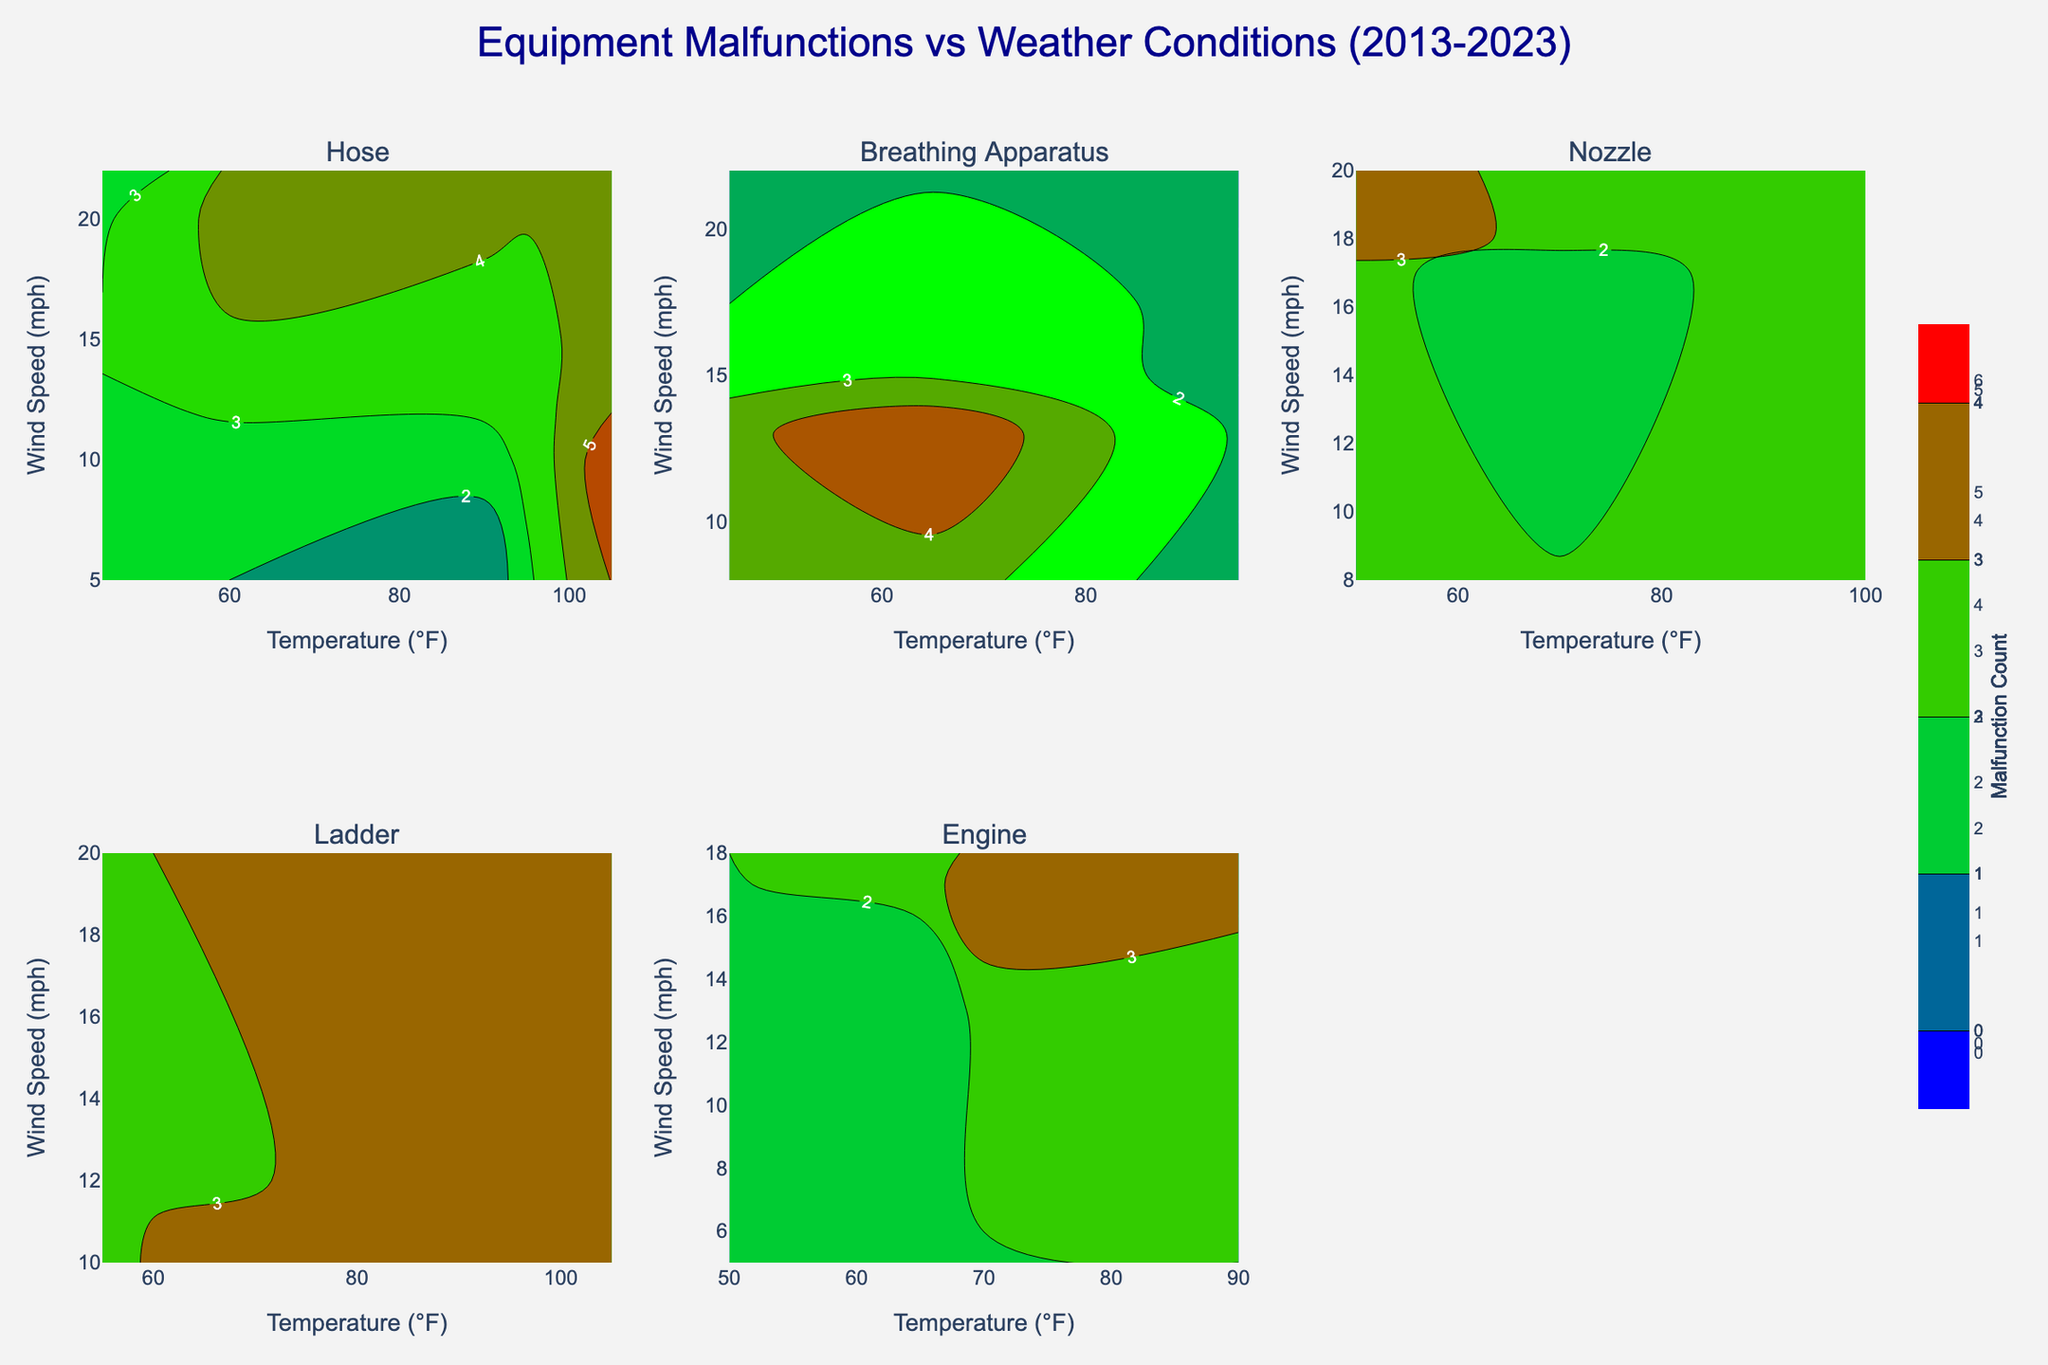What's the title of the figure? The title of the figure is usually displayed prominently at the top of the plot, and it provides a concise description of the data being presented. In this case, it reads "Equipment Malfunctions vs Weather Conditions (2013-2023)."
Answer: Equipment Malfunctions vs Weather Conditions (2013-2023) What do the color variations represent in each contour plot? The color variations in the contour plots represent the malfunction count of the equipment. The color scale ranges from blue (low malfunction count) to red (high malfunction count), with green indicating a mid-range count.
Answer: Malfunction count Which equipment type has the highest peak contour of malfunctions? By comparing the contour plots of each equipment type, we can identify which one shows the highest peak malfunction count. The "Hose" subplot has the highest peak, reaching up to 6 malfunctions.
Answer: Hose What are the axes of each subplot? The x-axis represents the temperature in degrees Fahrenheit (°F), and the y-axis represents the wind speed in miles per hour (mph) in each subplot. These axes are consistent across all equipment types.
Answer: Temperature (°F) and Wind Speed (mph) For which equipment type do malfunctions appear to be most sensitive to changes in temperature? Examining the contour lines' density and variation in response to temperature changes helps determine sensitivity. The "Hose" equipment type shows significant variations in malfunction counts along the temperature axis.
Answer: Hose Between the Breathing Apparatus and the Engine, which one has a greater maximum malfunction count? Comparing the peak values in the contour plots, the Breathing Apparatus has a maximum malfunction count of 5, while the Engine has a maximum count of 4.
Answer: Breathing Apparatus Are there any equipment types where malfunction counts are relatively unaffected by wind speed? Analyzing the contour plots for flat or sparse lines parallel to the wind speed (y-axis) indicates minimal impact of wind speed. The "Ladder" and "Nozzle" equipment types show less variation in malfunctions with changes in wind speed.
Answer: Ladder and Nozzle Which equipment type has the most varying malfunction count due to wind speed changes at moderate temperatures (e.g., around 60-70°F)? By looking at the contour lines for the specified temperature range, the "Engine" shows significant changes in malfunction counts due to wind speed variations around 60-70°F.
Answer: Engine During which temperature range does the "Nozzle" show the highest number of malfunctions? By examining the highest contour peaks in the "Nozzle" subplot, the most malfunctions occur in the 85-100°F temperature range.
Answer: 85-100°F How do the malfunctions of the "Breathing Apparatus" compare in very high and low wind speeds? Comparing contour lines in the "Breathing Apparatus" plot at extremes along the wind speed axis, the count is higher in very low wind speeds and decreases significantly in very high wind speeds.
Answer: Higher at low wind speeds 